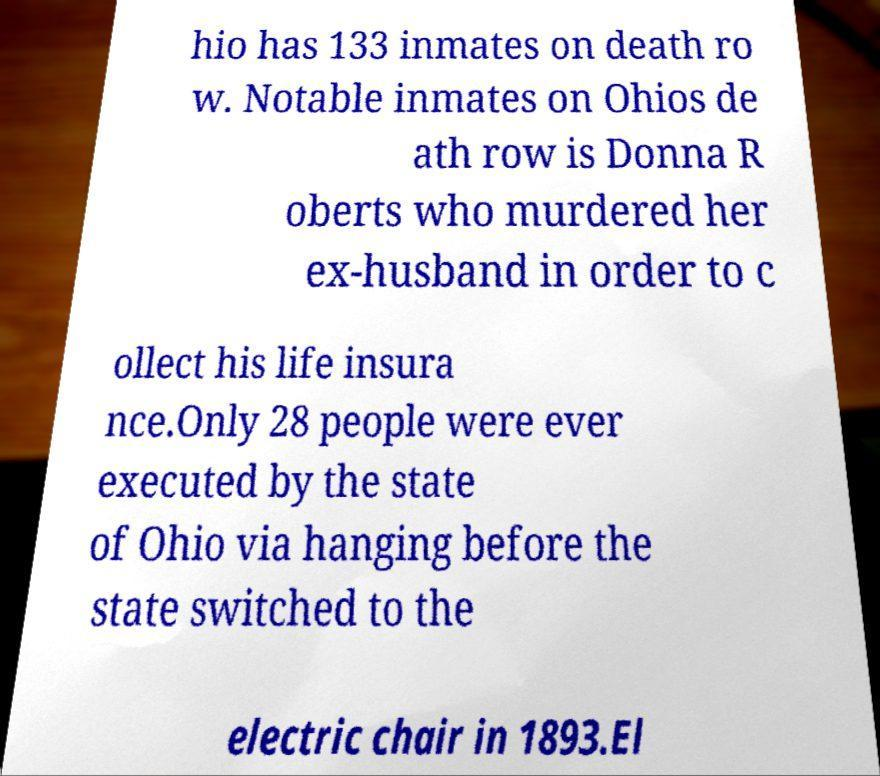Could you assist in decoding the text presented in this image and type it out clearly? hio has 133 inmates on death ro w. Notable inmates on Ohios de ath row is Donna R oberts who murdered her ex-husband in order to c ollect his life insura nce.Only 28 people were ever executed by the state of Ohio via hanging before the state switched to the electric chair in 1893.El 